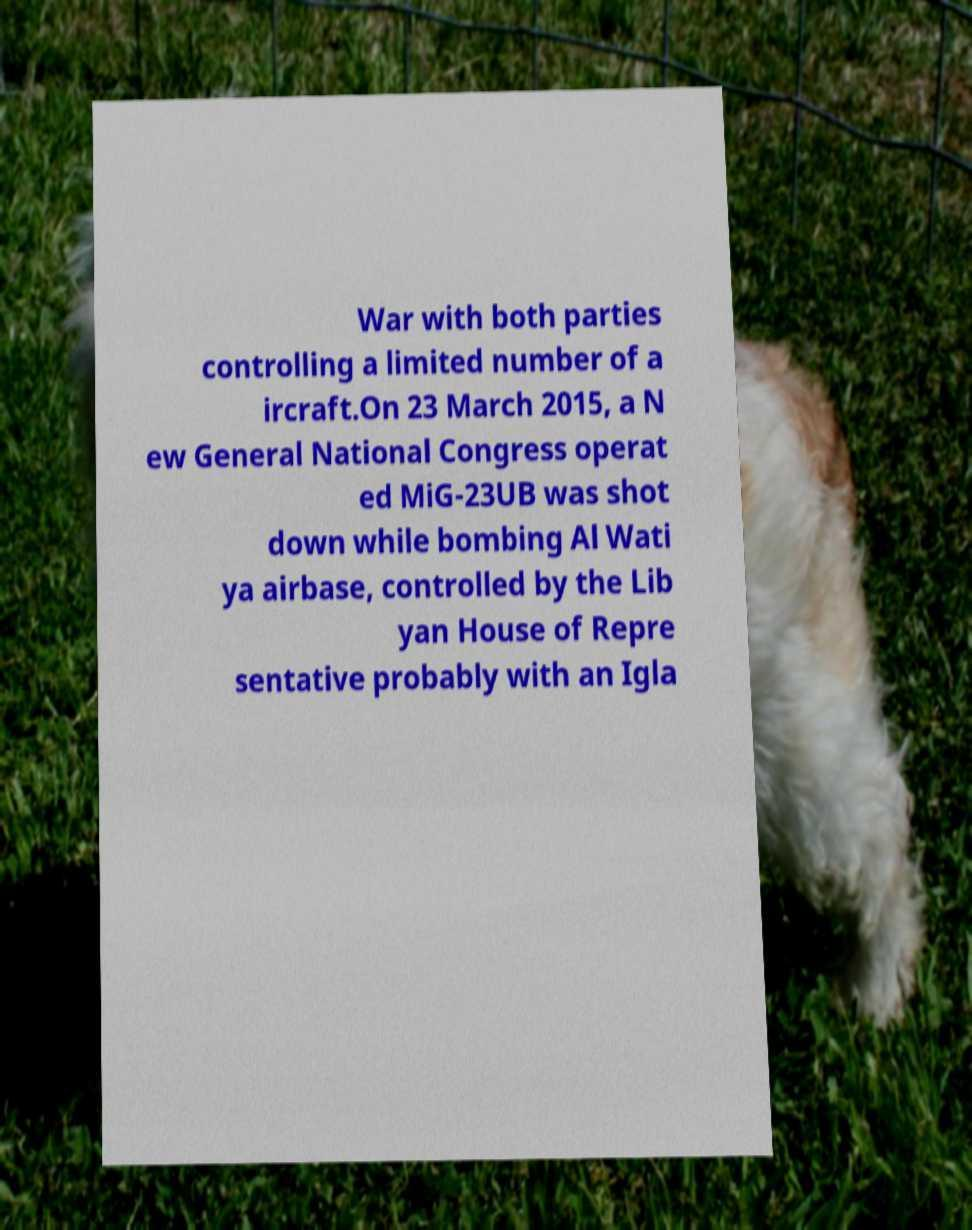I need the written content from this picture converted into text. Can you do that? War with both parties controlling a limited number of a ircraft.On 23 March 2015, a N ew General National Congress operat ed MiG-23UB was shot down while bombing Al Wati ya airbase, controlled by the Lib yan House of Repre sentative probably with an Igla 